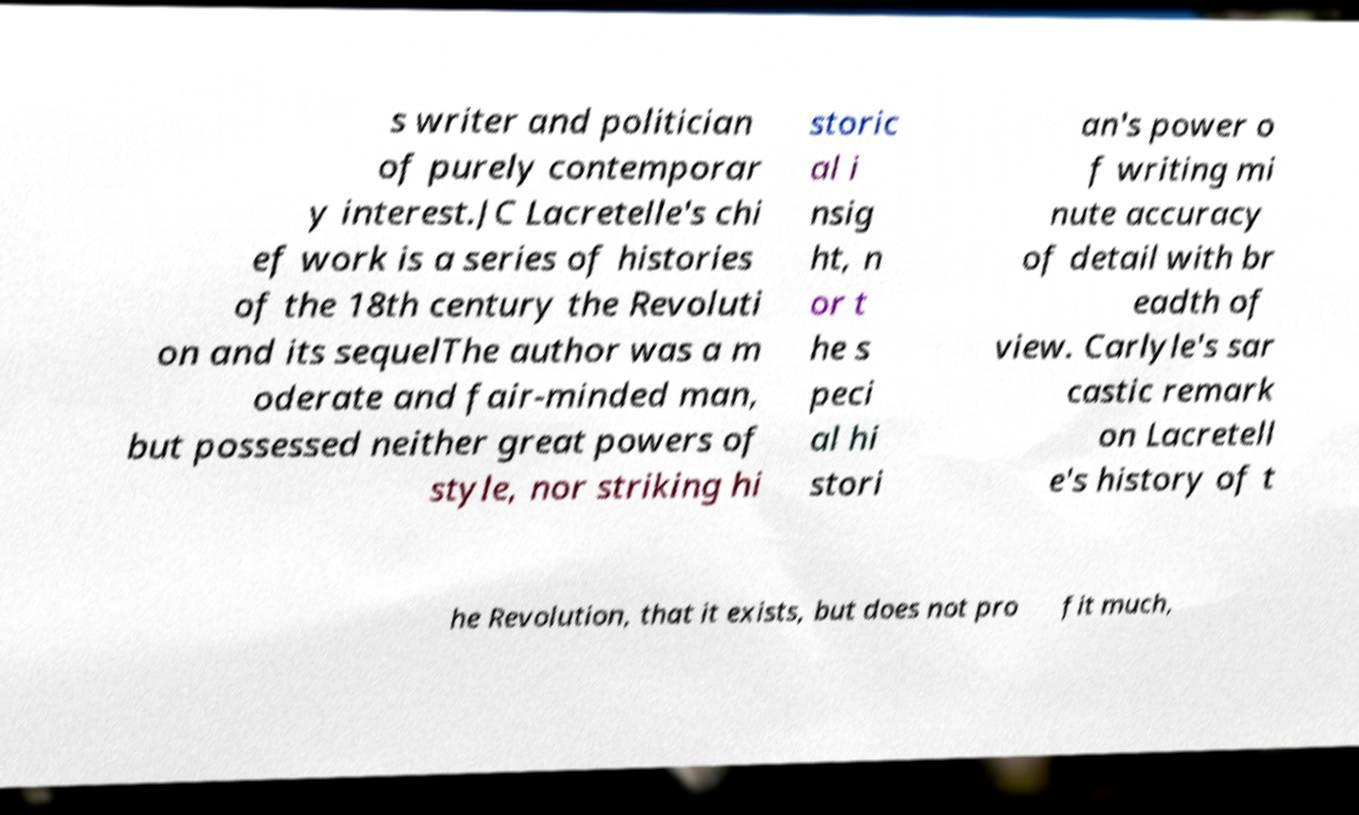What messages or text are displayed in this image? I need them in a readable, typed format. s writer and politician of purely contemporar y interest.JC Lacretelle's chi ef work is a series of histories of the 18th century the Revoluti on and its sequelThe author was a m oderate and fair-minded man, but possessed neither great powers of style, nor striking hi storic al i nsig ht, n or t he s peci al hi stori an's power o f writing mi nute accuracy of detail with br eadth of view. Carlyle's sar castic remark on Lacretell e's history of t he Revolution, that it exists, but does not pro fit much, 